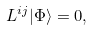<formula> <loc_0><loc_0><loc_500><loc_500>L ^ { i j } | \Phi \rangle = 0 ,</formula> 